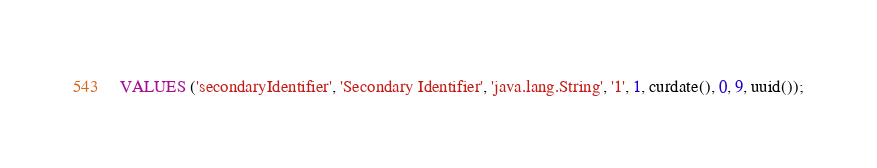<code> <loc_0><loc_0><loc_500><loc_500><_SQL_>VALUES ('secondaryIdentifier', 'Secondary Identifier', 'java.lang.String', '1', 1, curdate(), 0, 9, uuid());</code> 